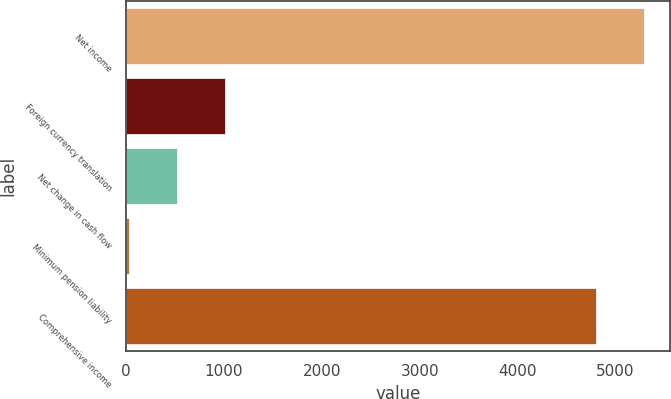<chart> <loc_0><loc_0><loc_500><loc_500><bar_chart><fcel>Net income<fcel>Foreign currency translation<fcel>Net change in cash flow<fcel>Minimum pension liability<fcel>Comprehensive income<nl><fcel>5296.4<fcel>1007.8<fcel>516.4<fcel>25<fcel>4805<nl></chart> 